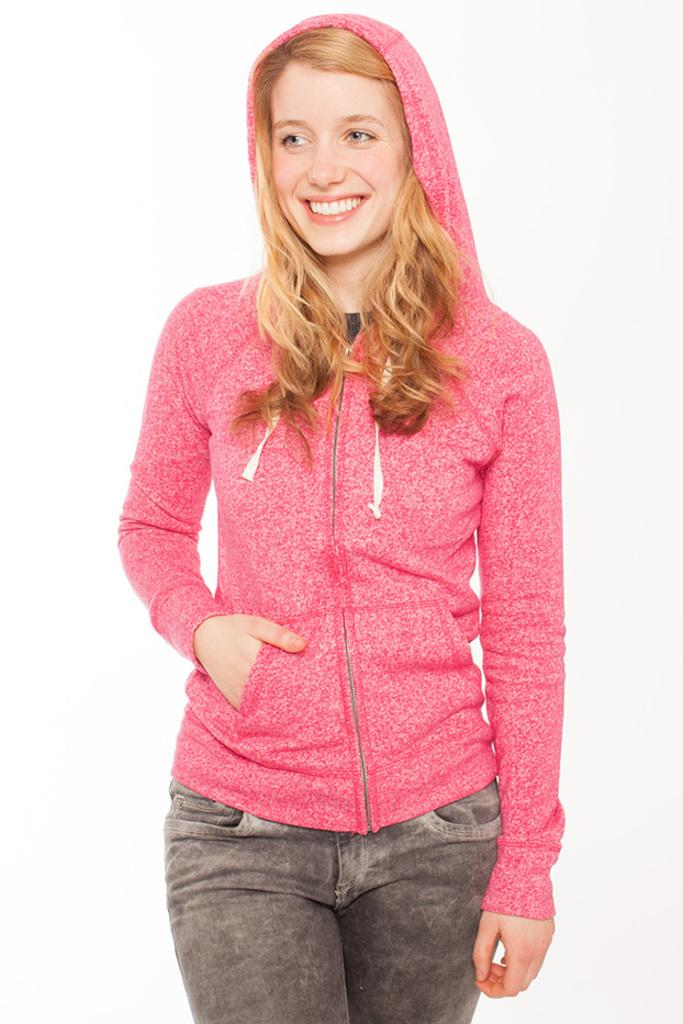Who is the main subject in the image? There is a lady in the image. What is the lady wearing? The lady is wearing a jacket. What is the lady doing in the image? The lady is standing and smiling. What is the color of the background in the image? The background of the image is white. Can you hear the lady coughing in the image? There is no sound in the image, so it is not possible to hear the lady coughing. 